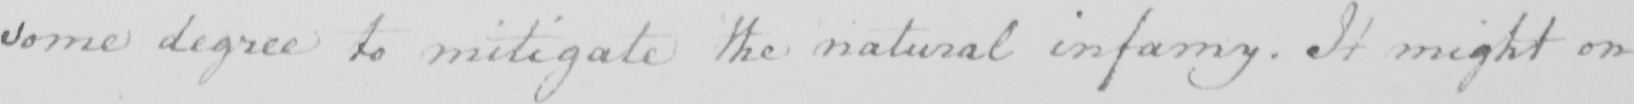Please provide the text content of this handwritten line. some degree to mitigate the natural infamy . It might on 